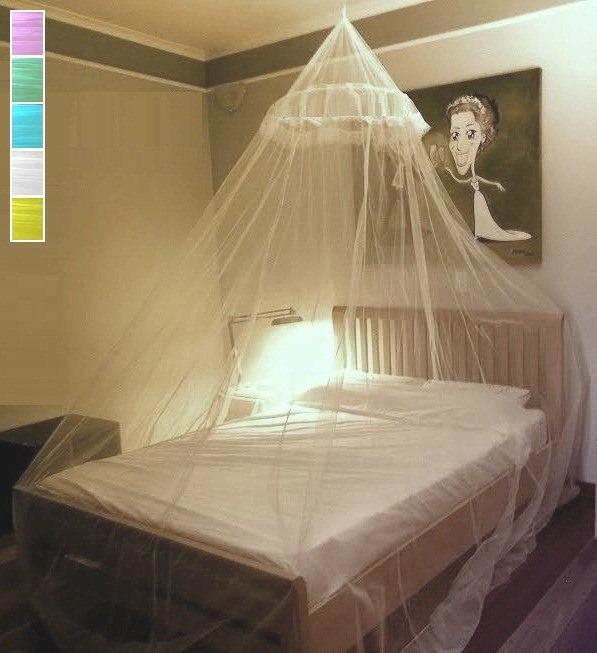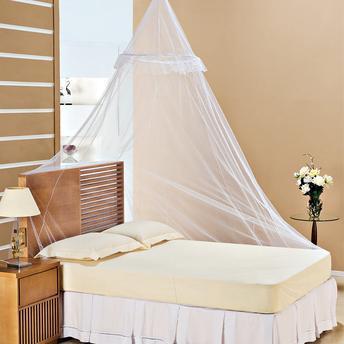The first image is the image on the left, the second image is the image on the right. Analyze the images presented: Is the assertion "Exactly one canopy is attached to the ceiling." valid? Answer yes or no. No. The first image is the image on the left, the second image is the image on the right. Analyze the images presented: Is the assertion "There are two white canopies; one hanging from the ceiling and the other mounted on the back wall." valid? Answer yes or no. No. 